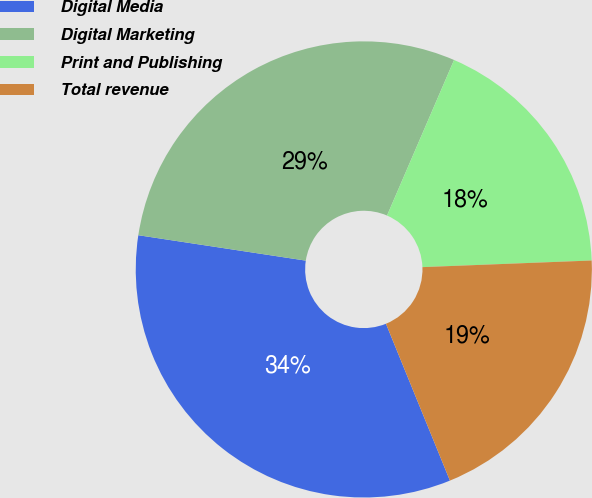Convert chart to OTSL. <chart><loc_0><loc_0><loc_500><loc_500><pie_chart><fcel>Digital Media<fcel>Digital Marketing<fcel>Print and Publishing<fcel>Total revenue<nl><fcel>33.56%<fcel>29.08%<fcel>17.9%<fcel>19.46%<nl></chart> 